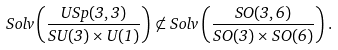Convert formula to latex. <formula><loc_0><loc_0><loc_500><loc_500>S o l v \left ( \frac { U S p ( 3 , 3 ) } { S U ( 3 ) \times { U } ( 1 ) } \right ) \not \subset S o l v \left ( \frac { S O ( 3 , 6 ) } { S O ( 3 ) \times S O ( 6 ) } \right ) .</formula> 